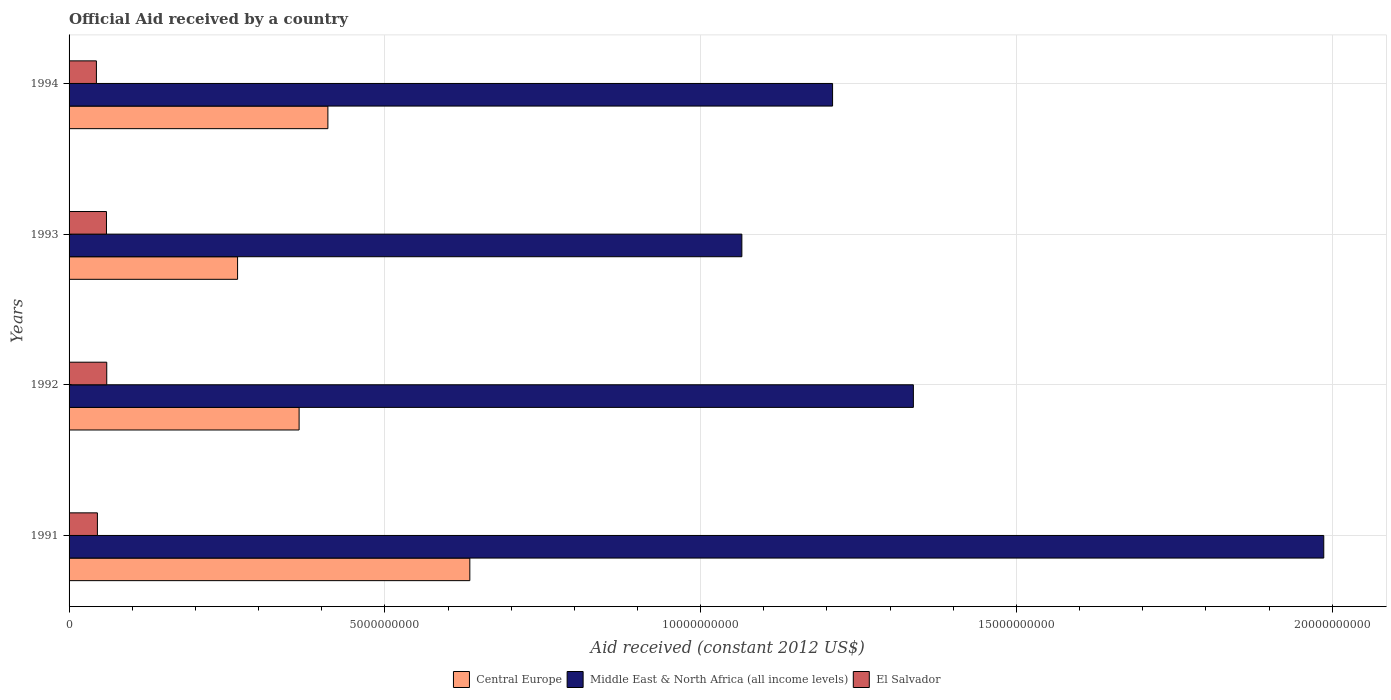How many groups of bars are there?
Keep it short and to the point. 4. Are the number of bars per tick equal to the number of legend labels?
Ensure brevity in your answer.  Yes. How many bars are there on the 4th tick from the bottom?
Offer a terse response. 3. What is the label of the 2nd group of bars from the top?
Your response must be concise. 1993. In how many cases, is the number of bars for a given year not equal to the number of legend labels?
Offer a terse response. 0. What is the net official aid received in El Salvador in 1991?
Give a very brief answer. 4.49e+08. Across all years, what is the maximum net official aid received in Central Europe?
Your answer should be compact. 6.35e+09. Across all years, what is the minimum net official aid received in Central Europe?
Offer a very short reply. 2.67e+09. In which year was the net official aid received in Central Europe maximum?
Make the answer very short. 1991. What is the total net official aid received in El Salvador in the graph?
Your answer should be compact. 2.07e+09. What is the difference between the net official aid received in Middle East & North Africa (all income levels) in 1991 and that in 1993?
Provide a short and direct response. 9.21e+09. What is the difference between the net official aid received in El Salvador in 1993 and the net official aid received in Central Europe in 1991?
Your response must be concise. -5.75e+09. What is the average net official aid received in Middle East & North Africa (all income levels) per year?
Give a very brief answer. 1.40e+1. In the year 1994, what is the difference between the net official aid received in Central Europe and net official aid received in El Salvador?
Your answer should be compact. 3.67e+09. In how many years, is the net official aid received in El Salvador greater than 1000000000 US$?
Keep it short and to the point. 0. What is the ratio of the net official aid received in Middle East & North Africa (all income levels) in 1991 to that in 1994?
Your answer should be compact. 1.64. Is the net official aid received in Central Europe in 1991 less than that in 1993?
Offer a terse response. No. What is the difference between the highest and the second highest net official aid received in Middle East & North Africa (all income levels)?
Provide a short and direct response. 6.50e+09. What is the difference between the highest and the lowest net official aid received in Central Europe?
Provide a succinct answer. 3.68e+09. In how many years, is the net official aid received in Central Europe greater than the average net official aid received in Central Europe taken over all years?
Your answer should be compact. 1. Is the sum of the net official aid received in Central Europe in 1991 and 1994 greater than the maximum net official aid received in El Salvador across all years?
Your answer should be compact. Yes. What does the 3rd bar from the top in 1993 represents?
Your answer should be very brief. Central Europe. What does the 1st bar from the bottom in 1991 represents?
Offer a terse response. Central Europe. Are all the bars in the graph horizontal?
Offer a very short reply. Yes. Where does the legend appear in the graph?
Keep it short and to the point. Bottom center. How many legend labels are there?
Provide a short and direct response. 3. What is the title of the graph?
Offer a terse response. Official Aid received by a country. Does "Curacao" appear as one of the legend labels in the graph?
Provide a short and direct response. No. What is the label or title of the X-axis?
Offer a very short reply. Aid received (constant 2012 US$). What is the label or title of the Y-axis?
Offer a terse response. Years. What is the Aid received (constant 2012 US$) of Central Europe in 1991?
Make the answer very short. 6.35e+09. What is the Aid received (constant 2012 US$) in Middle East & North Africa (all income levels) in 1991?
Your response must be concise. 1.99e+1. What is the Aid received (constant 2012 US$) in El Salvador in 1991?
Ensure brevity in your answer.  4.49e+08. What is the Aid received (constant 2012 US$) in Central Europe in 1992?
Offer a terse response. 3.64e+09. What is the Aid received (constant 2012 US$) in Middle East & North Africa (all income levels) in 1992?
Ensure brevity in your answer.  1.34e+1. What is the Aid received (constant 2012 US$) of El Salvador in 1992?
Make the answer very short. 5.97e+08. What is the Aid received (constant 2012 US$) in Central Europe in 1993?
Make the answer very short. 2.67e+09. What is the Aid received (constant 2012 US$) of Middle East & North Africa (all income levels) in 1993?
Give a very brief answer. 1.07e+1. What is the Aid received (constant 2012 US$) of El Salvador in 1993?
Your answer should be very brief. 5.92e+08. What is the Aid received (constant 2012 US$) of Central Europe in 1994?
Give a very brief answer. 4.10e+09. What is the Aid received (constant 2012 US$) of Middle East & North Africa (all income levels) in 1994?
Offer a terse response. 1.21e+1. What is the Aid received (constant 2012 US$) in El Salvador in 1994?
Offer a terse response. 4.33e+08. Across all years, what is the maximum Aid received (constant 2012 US$) in Central Europe?
Provide a succinct answer. 6.35e+09. Across all years, what is the maximum Aid received (constant 2012 US$) in Middle East & North Africa (all income levels)?
Ensure brevity in your answer.  1.99e+1. Across all years, what is the maximum Aid received (constant 2012 US$) of El Salvador?
Offer a terse response. 5.97e+08. Across all years, what is the minimum Aid received (constant 2012 US$) of Central Europe?
Give a very brief answer. 2.67e+09. Across all years, what is the minimum Aid received (constant 2012 US$) of Middle East & North Africa (all income levels)?
Give a very brief answer. 1.07e+1. Across all years, what is the minimum Aid received (constant 2012 US$) of El Salvador?
Your response must be concise. 4.33e+08. What is the total Aid received (constant 2012 US$) in Central Europe in the graph?
Give a very brief answer. 1.68e+1. What is the total Aid received (constant 2012 US$) of Middle East & North Africa (all income levels) in the graph?
Your response must be concise. 5.60e+1. What is the total Aid received (constant 2012 US$) of El Salvador in the graph?
Offer a terse response. 2.07e+09. What is the difference between the Aid received (constant 2012 US$) in Central Europe in 1991 and that in 1992?
Ensure brevity in your answer.  2.70e+09. What is the difference between the Aid received (constant 2012 US$) in Middle East & North Africa (all income levels) in 1991 and that in 1992?
Your response must be concise. 6.50e+09. What is the difference between the Aid received (constant 2012 US$) of El Salvador in 1991 and that in 1992?
Provide a short and direct response. -1.48e+08. What is the difference between the Aid received (constant 2012 US$) of Central Europe in 1991 and that in 1993?
Keep it short and to the point. 3.68e+09. What is the difference between the Aid received (constant 2012 US$) of Middle East & North Africa (all income levels) in 1991 and that in 1993?
Give a very brief answer. 9.21e+09. What is the difference between the Aid received (constant 2012 US$) in El Salvador in 1991 and that in 1993?
Provide a short and direct response. -1.43e+08. What is the difference between the Aid received (constant 2012 US$) of Central Europe in 1991 and that in 1994?
Provide a short and direct response. 2.25e+09. What is the difference between the Aid received (constant 2012 US$) in Middle East & North Africa (all income levels) in 1991 and that in 1994?
Keep it short and to the point. 7.78e+09. What is the difference between the Aid received (constant 2012 US$) in El Salvador in 1991 and that in 1994?
Your response must be concise. 1.58e+07. What is the difference between the Aid received (constant 2012 US$) in Central Europe in 1992 and that in 1993?
Give a very brief answer. 9.74e+08. What is the difference between the Aid received (constant 2012 US$) in Middle East & North Africa (all income levels) in 1992 and that in 1993?
Provide a short and direct response. 2.72e+09. What is the difference between the Aid received (constant 2012 US$) of El Salvador in 1992 and that in 1993?
Provide a short and direct response. 4.57e+06. What is the difference between the Aid received (constant 2012 US$) of Central Europe in 1992 and that in 1994?
Give a very brief answer. -4.56e+08. What is the difference between the Aid received (constant 2012 US$) in Middle East & North Africa (all income levels) in 1992 and that in 1994?
Provide a short and direct response. 1.28e+09. What is the difference between the Aid received (constant 2012 US$) in El Salvador in 1992 and that in 1994?
Your answer should be very brief. 1.64e+08. What is the difference between the Aid received (constant 2012 US$) in Central Europe in 1993 and that in 1994?
Ensure brevity in your answer.  -1.43e+09. What is the difference between the Aid received (constant 2012 US$) of Middle East & North Africa (all income levels) in 1993 and that in 1994?
Your response must be concise. -1.44e+09. What is the difference between the Aid received (constant 2012 US$) in El Salvador in 1993 and that in 1994?
Offer a terse response. 1.59e+08. What is the difference between the Aid received (constant 2012 US$) of Central Europe in 1991 and the Aid received (constant 2012 US$) of Middle East & North Africa (all income levels) in 1992?
Ensure brevity in your answer.  -7.02e+09. What is the difference between the Aid received (constant 2012 US$) of Central Europe in 1991 and the Aid received (constant 2012 US$) of El Salvador in 1992?
Ensure brevity in your answer.  5.75e+09. What is the difference between the Aid received (constant 2012 US$) of Middle East & North Africa (all income levels) in 1991 and the Aid received (constant 2012 US$) of El Salvador in 1992?
Provide a short and direct response. 1.93e+1. What is the difference between the Aid received (constant 2012 US$) of Central Europe in 1991 and the Aid received (constant 2012 US$) of Middle East & North Africa (all income levels) in 1993?
Provide a short and direct response. -4.31e+09. What is the difference between the Aid received (constant 2012 US$) in Central Europe in 1991 and the Aid received (constant 2012 US$) in El Salvador in 1993?
Provide a succinct answer. 5.75e+09. What is the difference between the Aid received (constant 2012 US$) of Middle East & North Africa (all income levels) in 1991 and the Aid received (constant 2012 US$) of El Salvador in 1993?
Ensure brevity in your answer.  1.93e+1. What is the difference between the Aid received (constant 2012 US$) of Central Europe in 1991 and the Aid received (constant 2012 US$) of Middle East & North Africa (all income levels) in 1994?
Ensure brevity in your answer.  -5.74e+09. What is the difference between the Aid received (constant 2012 US$) in Central Europe in 1991 and the Aid received (constant 2012 US$) in El Salvador in 1994?
Keep it short and to the point. 5.91e+09. What is the difference between the Aid received (constant 2012 US$) in Middle East & North Africa (all income levels) in 1991 and the Aid received (constant 2012 US$) in El Salvador in 1994?
Keep it short and to the point. 1.94e+1. What is the difference between the Aid received (constant 2012 US$) of Central Europe in 1992 and the Aid received (constant 2012 US$) of Middle East & North Africa (all income levels) in 1993?
Keep it short and to the point. -7.01e+09. What is the difference between the Aid received (constant 2012 US$) of Central Europe in 1992 and the Aid received (constant 2012 US$) of El Salvador in 1993?
Make the answer very short. 3.05e+09. What is the difference between the Aid received (constant 2012 US$) in Middle East & North Africa (all income levels) in 1992 and the Aid received (constant 2012 US$) in El Salvador in 1993?
Your answer should be very brief. 1.28e+1. What is the difference between the Aid received (constant 2012 US$) in Central Europe in 1992 and the Aid received (constant 2012 US$) in Middle East & North Africa (all income levels) in 1994?
Make the answer very short. -8.45e+09. What is the difference between the Aid received (constant 2012 US$) of Central Europe in 1992 and the Aid received (constant 2012 US$) of El Salvador in 1994?
Provide a succinct answer. 3.21e+09. What is the difference between the Aid received (constant 2012 US$) of Middle East & North Africa (all income levels) in 1992 and the Aid received (constant 2012 US$) of El Salvador in 1994?
Give a very brief answer. 1.29e+1. What is the difference between the Aid received (constant 2012 US$) of Central Europe in 1993 and the Aid received (constant 2012 US$) of Middle East & North Africa (all income levels) in 1994?
Keep it short and to the point. -9.42e+09. What is the difference between the Aid received (constant 2012 US$) in Central Europe in 1993 and the Aid received (constant 2012 US$) in El Salvador in 1994?
Offer a very short reply. 2.24e+09. What is the difference between the Aid received (constant 2012 US$) of Middle East & North Africa (all income levels) in 1993 and the Aid received (constant 2012 US$) of El Salvador in 1994?
Offer a very short reply. 1.02e+1. What is the average Aid received (constant 2012 US$) of Central Europe per year?
Ensure brevity in your answer.  4.19e+09. What is the average Aid received (constant 2012 US$) of Middle East & North Africa (all income levels) per year?
Your answer should be compact. 1.40e+1. What is the average Aid received (constant 2012 US$) of El Salvador per year?
Make the answer very short. 5.18e+08. In the year 1991, what is the difference between the Aid received (constant 2012 US$) of Central Europe and Aid received (constant 2012 US$) of Middle East & North Africa (all income levels)?
Ensure brevity in your answer.  -1.35e+1. In the year 1991, what is the difference between the Aid received (constant 2012 US$) of Central Europe and Aid received (constant 2012 US$) of El Salvador?
Ensure brevity in your answer.  5.90e+09. In the year 1991, what is the difference between the Aid received (constant 2012 US$) of Middle East & North Africa (all income levels) and Aid received (constant 2012 US$) of El Salvador?
Your answer should be very brief. 1.94e+1. In the year 1992, what is the difference between the Aid received (constant 2012 US$) of Central Europe and Aid received (constant 2012 US$) of Middle East & North Africa (all income levels)?
Offer a terse response. -9.73e+09. In the year 1992, what is the difference between the Aid received (constant 2012 US$) of Central Europe and Aid received (constant 2012 US$) of El Salvador?
Offer a very short reply. 3.05e+09. In the year 1992, what is the difference between the Aid received (constant 2012 US$) of Middle East & North Africa (all income levels) and Aid received (constant 2012 US$) of El Salvador?
Provide a succinct answer. 1.28e+1. In the year 1993, what is the difference between the Aid received (constant 2012 US$) in Central Europe and Aid received (constant 2012 US$) in Middle East & North Africa (all income levels)?
Ensure brevity in your answer.  -7.98e+09. In the year 1993, what is the difference between the Aid received (constant 2012 US$) of Central Europe and Aid received (constant 2012 US$) of El Salvador?
Your answer should be compact. 2.08e+09. In the year 1993, what is the difference between the Aid received (constant 2012 US$) of Middle East & North Africa (all income levels) and Aid received (constant 2012 US$) of El Salvador?
Keep it short and to the point. 1.01e+1. In the year 1994, what is the difference between the Aid received (constant 2012 US$) of Central Europe and Aid received (constant 2012 US$) of Middle East & North Africa (all income levels)?
Ensure brevity in your answer.  -7.99e+09. In the year 1994, what is the difference between the Aid received (constant 2012 US$) of Central Europe and Aid received (constant 2012 US$) of El Salvador?
Provide a succinct answer. 3.67e+09. In the year 1994, what is the difference between the Aid received (constant 2012 US$) in Middle East & North Africa (all income levels) and Aid received (constant 2012 US$) in El Salvador?
Offer a very short reply. 1.17e+1. What is the ratio of the Aid received (constant 2012 US$) of Central Europe in 1991 to that in 1992?
Your answer should be compact. 1.74. What is the ratio of the Aid received (constant 2012 US$) in Middle East & North Africa (all income levels) in 1991 to that in 1992?
Your answer should be very brief. 1.49. What is the ratio of the Aid received (constant 2012 US$) in El Salvador in 1991 to that in 1992?
Your answer should be compact. 0.75. What is the ratio of the Aid received (constant 2012 US$) of Central Europe in 1991 to that in 1993?
Offer a very short reply. 2.38. What is the ratio of the Aid received (constant 2012 US$) of Middle East & North Africa (all income levels) in 1991 to that in 1993?
Your response must be concise. 1.86. What is the ratio of the Aid received (constant 2012 US$) in El Salvador in 1991 to that in 1993?
Ensure brevity in your answer.  0.76. What is the ratio of the Aid received (constant 2012 US$) of Central Europe in 1991 to that in 1994?
Give a very brief answer. 1.55. What is the ratio of the Aid received (constant 2012 US$) in Middle East & North Africa (all income levels) in 1991 to that in 1994?
Ensure brevity in your answer.  1.64. What is the ratio of the Aid received (constant 2012 US$) in El Salvador in 1991 to that in 1994?
Provide a succinct answer. 1.04. What is the ratio of the Aid received (constant 2012 US$) of Central Europe in 1992 to that in 1993?
Keep it short and to the point. 1.37. What is the ratio of the Aid received (constant 2012 US$) of Middle East & North Africa (all income levels) in 1992 to that in 1993?
Your answer should be compact. 1.25. What is the ratio of the Aid received (constant 2012 US$) of El Salvador in 1992 to that in 1993?
Offer a very short reply. 1.01. What is the ratio of the Aid received (constant 2012 US$) of Central Europe in 1992 to that in 1994?
Your answer should be very brief. 0.89. What is the ratio of the Aid received (constant 2012 US$) of Middle East & North Africa (all income levels) in 1992 to that in 1994?
Give a very brief answer. 1.11. What is the ratio of the Aid received (constant 2012 US$) in El Salvador in 1992 to that in 1994?
Provide a succinct answer. 1.38. What is the ratio of the Aid received (constant 2012 US$) in Central Europe in 1993 to that in 1994?
Make the answer very short. 0.65. What is the ratio of the Aid received (constant 2012 US$) of Middle East & North Africa (all income levels) in 1993 to that in 1994?
Provide a short and direct response. 0.88. What is the ratio of the Aid received (constant 2012 US$) of El Salvador in 1993 to that in 1994?
Your answer should be very brief. 1.37. What is the difference between the highest and the second highest Aid received (constant 2012 US$) of Central Europe?
Keep it short and to the point. 2.25e+09. What is the difference between the highest and the second highest Aid received (constant 2012 US$) in Middle East & North Africa (all income levels)?
Make the answer very short. 6.50e+09. What is the difference between the highest and the second highest Aid received (constant 2012 US$) in El Salvador?
Give a very brief answer. 4.57e+06. What is the difference between the highest and the lowest Aid received (constant 2012 US$) in Central Europe?
Provide a short and direct response. 3.68e+09. What is the difference between the highest and the lowest Aid received (constant 2012 US$) of Middle East & North Africa (all income levels)?
Ensure brevity in your answer.  9.21e+09. What is the difference between the highest and the lowest Aid received (constant 2012 US$) of El Salvador?
Ensure brevity in your answer.  1.64e+08. 